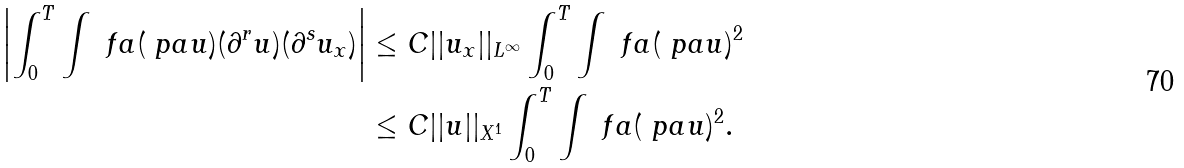Convert formula to latex. <formula><loc_0><loc_0><loc_500><loc_500>\left | \int _ { 0 } ^ { T } \int \ f a ( \ p a u ) ( \partial ^ { r } u ) ( \partial ^ { s } u _ { x } ) \right | & \leq C | | u _ { x } | | _ { L ^ { \infty } } \int _ { 0 } ^ { T } \int \ f a ( \ p a u ) ^ { 2 } \\ & \leq C | | u | | _ { X ^ { 1 } } \int _ { 0 } ^ { T } \int \ f a ( \ p a u ) ^ { 2 } .</formula> 